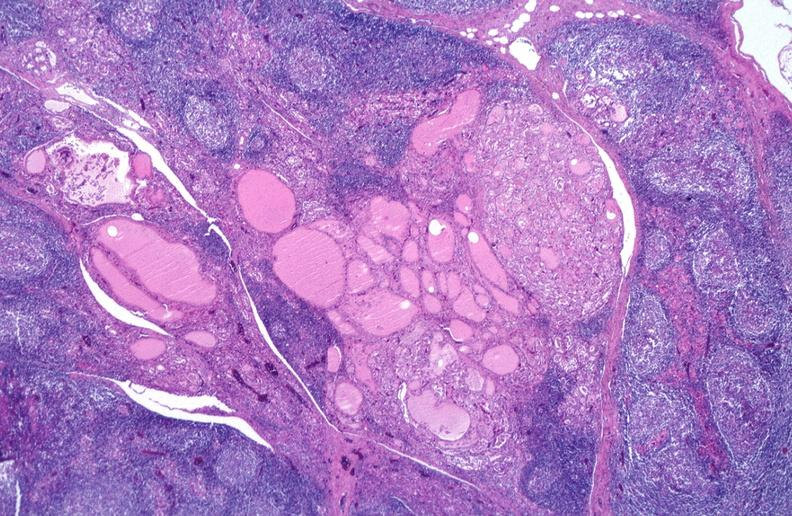does capillary show hashimoto 's thyroiditis?
Answer the question using a single word or phrase. No 